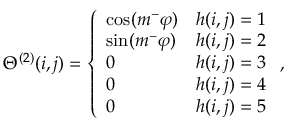Convert formula to latex. <formula><loc_0><loc_0><loc_500><loc_500>\Theta ^ { ( 2 ) } ( i , j ) = \left \{ \begin{array} { l l } { \cos ( m ^ { - } \varphi ) } & { h ( i , j ) = 1 } \\ { \sin ( m ^ { - } \varphi ) } & { h ( i , j ) = 2 } \\ { 0 } & { h ( i , j ) = 3 } \\ { 0 } & { h ( i , j ) = 4 } \\ { 0 } & { h ( i , j ) = 5 } \end{array} ,</formula> 